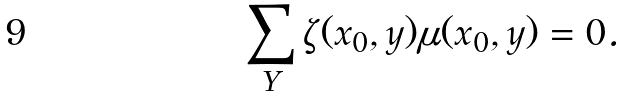Convert formula to latex. <formula><loc_0><loc_0><loc_500><loc_500>\sum _ { Y } \zeta ( x _ { 0 } , y ) \mu ( x _ { 0 } , y ) = 0 . \</formula> 